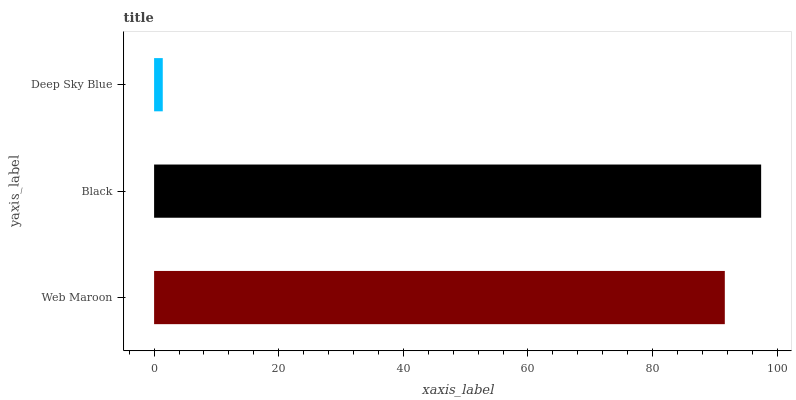Is Deep Sky Blue the minimum?
Answer yes or no. Yes. Is Black the maximum?
Answer yes or no. Yes. Is Black the minimum?
Answer yes or no. No. Is Deep Sky Blue the maximum?
Answer yes or no. No. Is Black greater than Deep Sky Blue?
Answer yes or no. Yes. Is Deep Sky Blue less than Black?
Answer yes or no. Yes. Is Deep Sky Blue greater than Black?
Answer yes or no. No. Is Black less than Deep Sky Blue?
Answer yes or no. No. Is Web Maroon the high median?
Answer yes or no. Yes. Is Web Maroon the low median?
Answer yes or no. Yes. Is Deep Sky Blue the high median?
Answer yes or no. No. Is Black the low median?
Answer yes or no. No. 